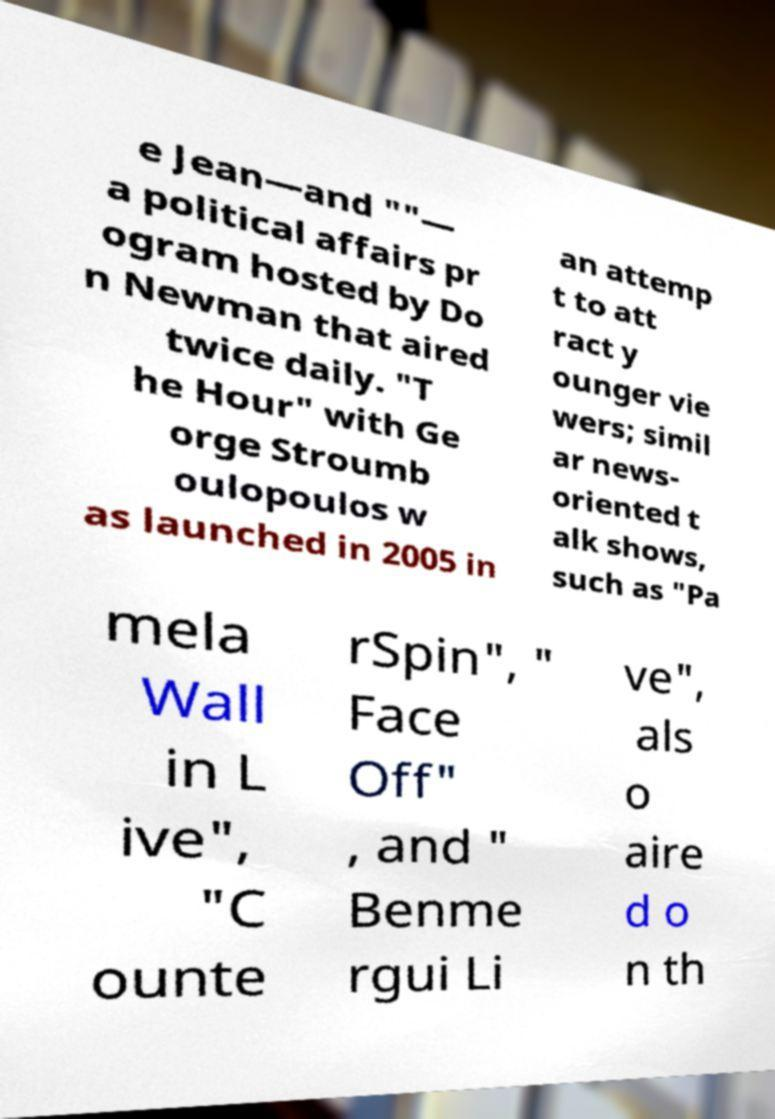Please read and relay the text visible in this image. What does it say? e Jean—and ""— a political affairs pr ogram hosted by Do n Newman that aired twice daily. "T he Hour" with Ge orge Stroumb oulopoulos w as launched in 2005 in an attemp t to att ract y ounger vie wers; simil ar news- oriented t alk shows, such as "Pa mela Wall in L ive", "C ounte rSpin", " Face Off" , and " Benme rgui Li ve", als o aire d o n th 